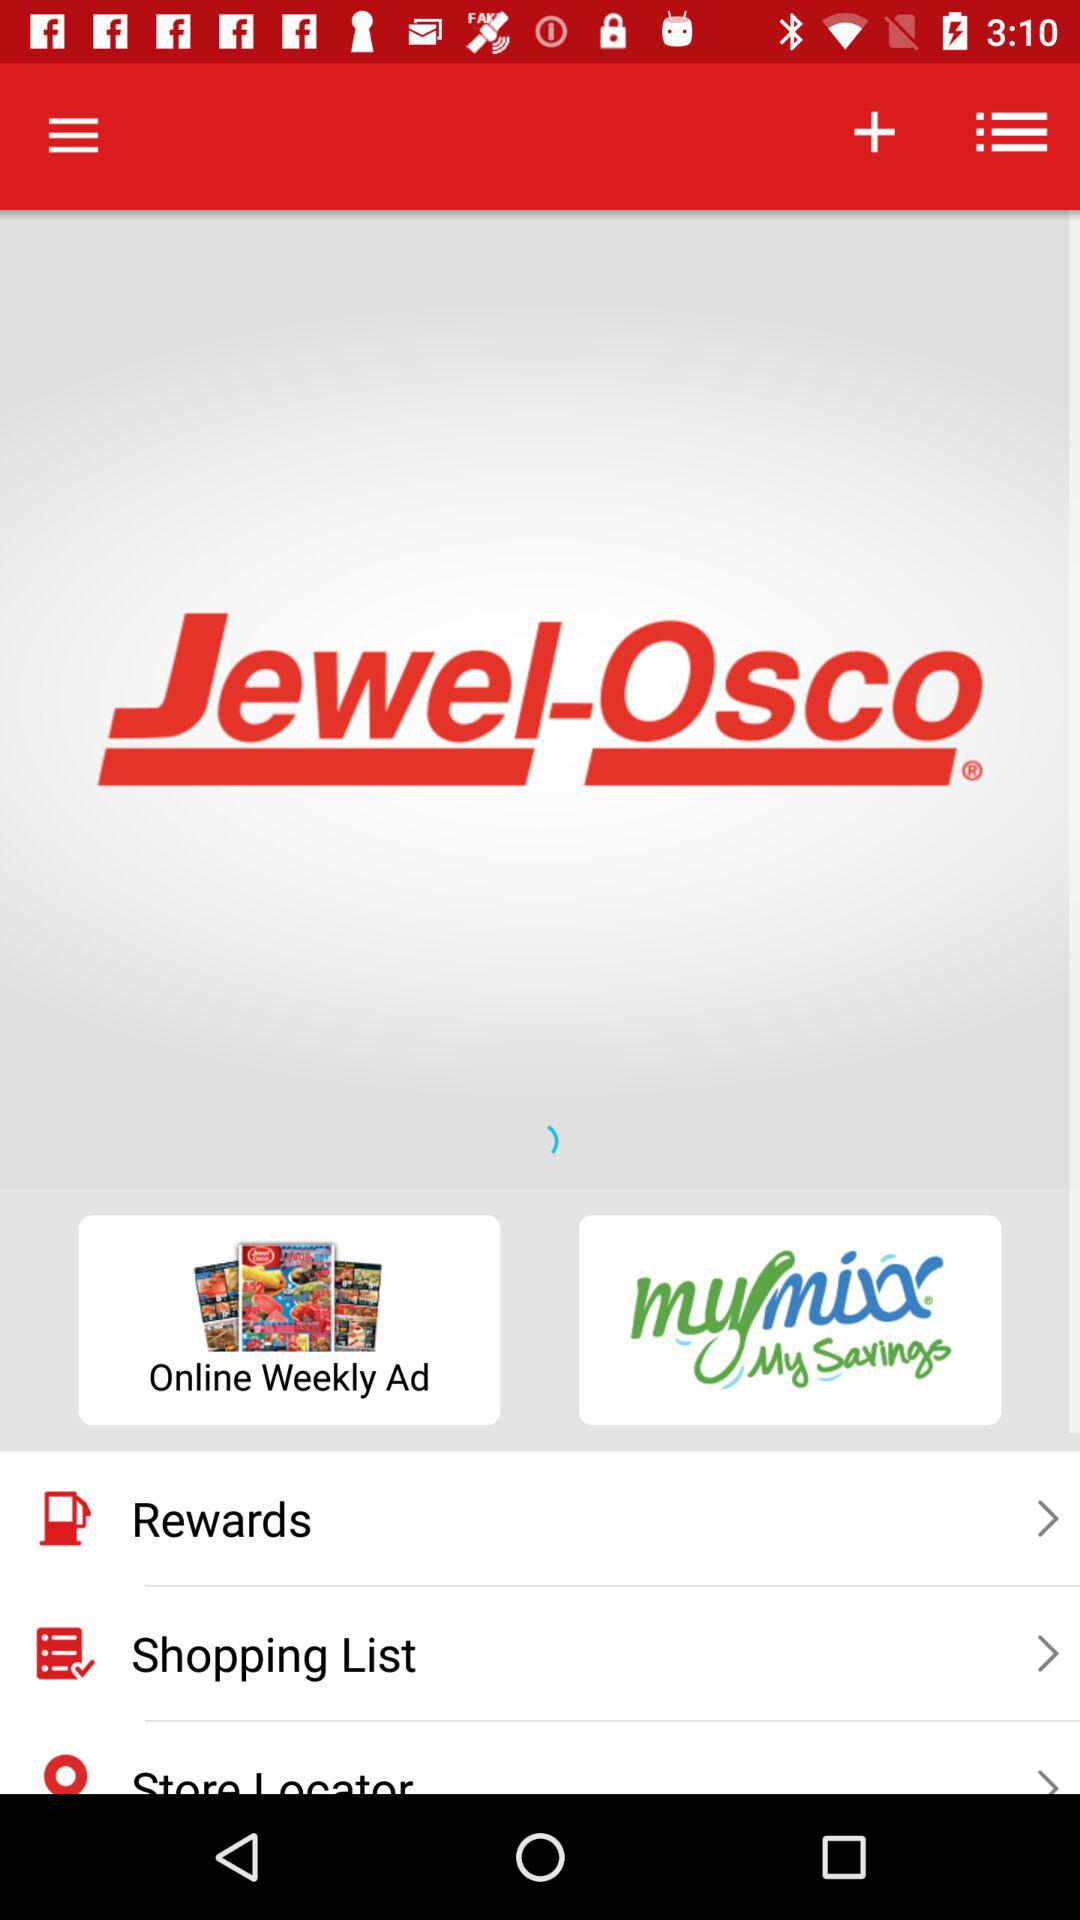What’s the app name? The app name is "Jewel-Osco". 